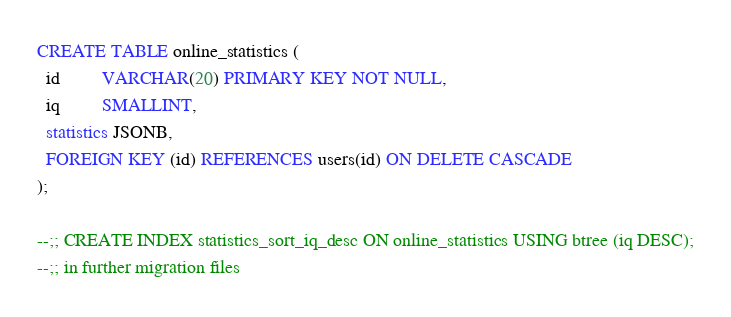Convert code to text. <code><loc_0><loc_0><loc_500><loc_500><_SQL_>CREATE TABLE online_statistics (
  id         VARCHAR(20) PRIMARY KEY NOT NULL,
  iq         SMALLINT,
  statistics JSONB,
  FOREIGN KEY (id) REFERENCES users(id) ON DELETE CASCADE
);

--;; CREATE INDEX statistics_sort_iq_desc ON online_statistics USING btree (iq DESC);
--;; in further migration files
</code> 